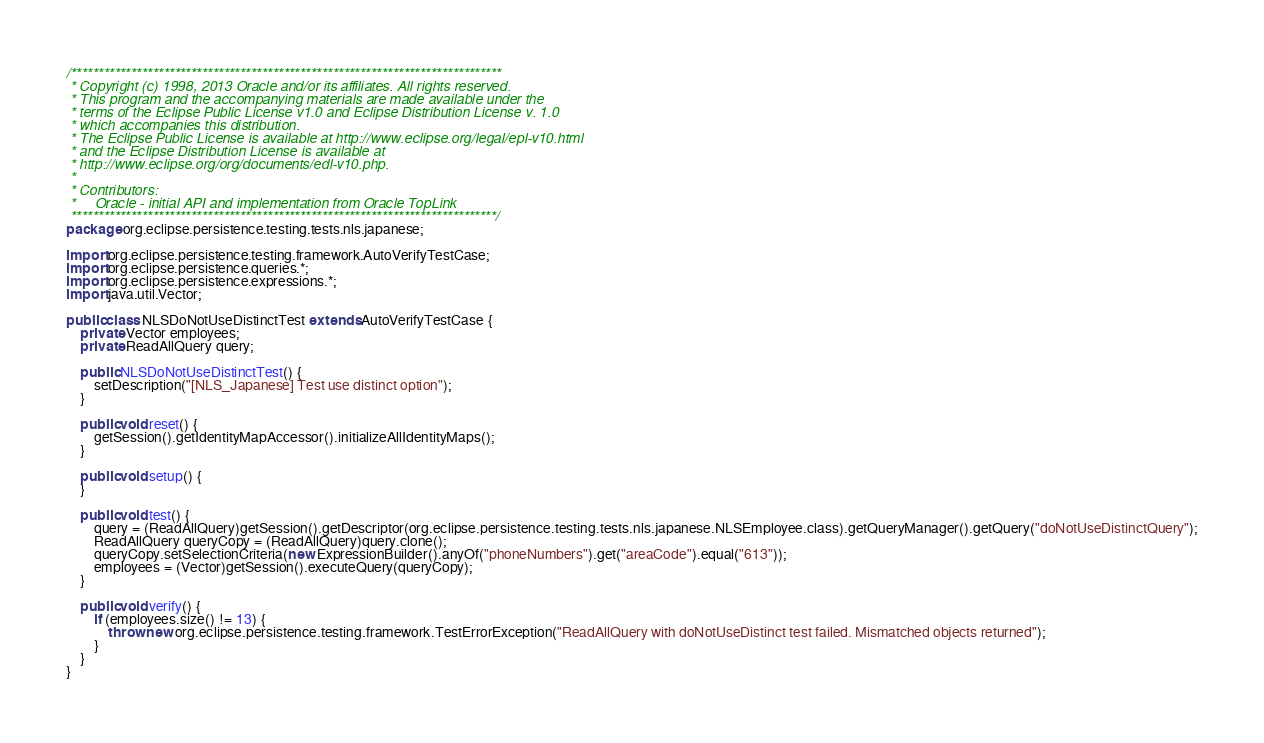<code> <loc_0><loc_0><loc_500><loc_500><_Java_>/*******************************************************************************
 * Copyright (c) 1998, 2013 Oracle and/or its affiliates. All rights reserved.
 * This program and the accompanying materials are made available under the 
 * terms of the Eclipse Public License v1.0 and Eclipse Distribution License v. 1.0 
 * which accompanies this distribution. 
 * The Eclipse Public License is available at http://www.eclipse.org/legal/epl-v10.html
 * and the Eclipse Distribution License is available at 
 * http://www.eclipse.org/org/documents/edl-v10.php.
 *
 * Contributors:
 *     Oracle - initial API and implementation from Oracle TopLink
 ******************************************************************************/
package org.eclipse.persistence.testing.tests.nls.japanese;

import org.eclipse.persistence.testing.framework.AutoVerifyTestCase;
import org.eclipse.persistence.queries.*;
import org.eclipse.persistence.expressions.*;
import java.util.Vector;

public class NLSDoNotUseDistinctTest extends AutoVerifyTestCase {
    private Vector employees;
    private ReadAllQuery query;

    public NLSDoNotUseDistinctTest() {
        setDescription("[NLS_Japanese] Test use distinct option");
    }

    public void reset() {
        getSession().getIdentityMapAccessor().initializeAllIdentityMaps();
    }

    public void setup() {
    }

    public void test() {
        query = (ReadAllQuery)getSession().getDescriptor(org.eclipse.persistence.testing.tests.nls.japanese.NLSEmployee.class).getQueryManager().getQuery("doNotUseDistinctQuery");
        ReadAllQuery queryCopy = (ReadAllQuery)query.clone();
        queryCopy.setSelectionCriteria(new ExpressionBuilder().anyOf("phoneNumbers").get("areaCode").equal("613"));
        employees = (Vector)getSession().executeQuery(queryCopy);
    }

    public void verify() {
        if (employees.size() != 13) {
            throw new org.eclipse.persistence.testing.framework.TestErrorException("ReadAllQuery with doNotUseDistinct test failed. Mismatched objects returned");
        }
    }
}
</code> 